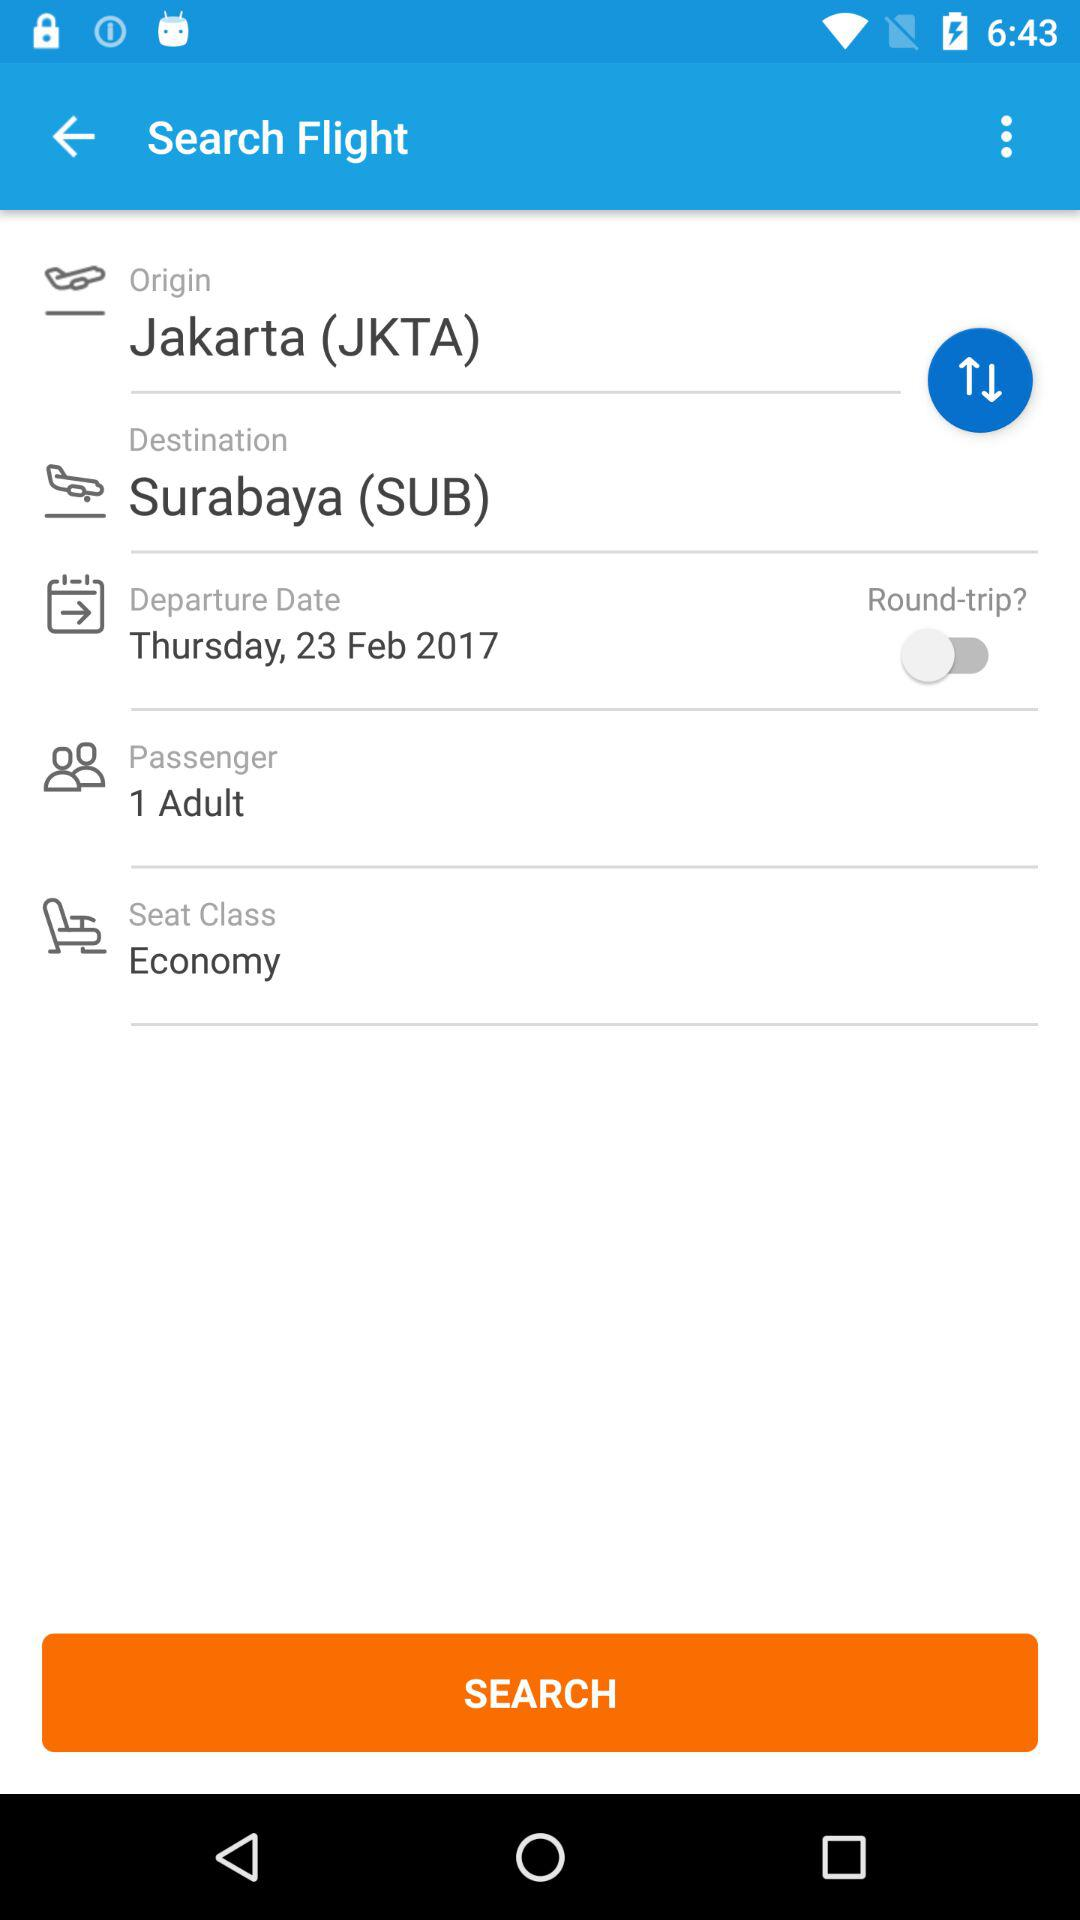Where would the flight land? The flight will land in Surabaya (SUB). 